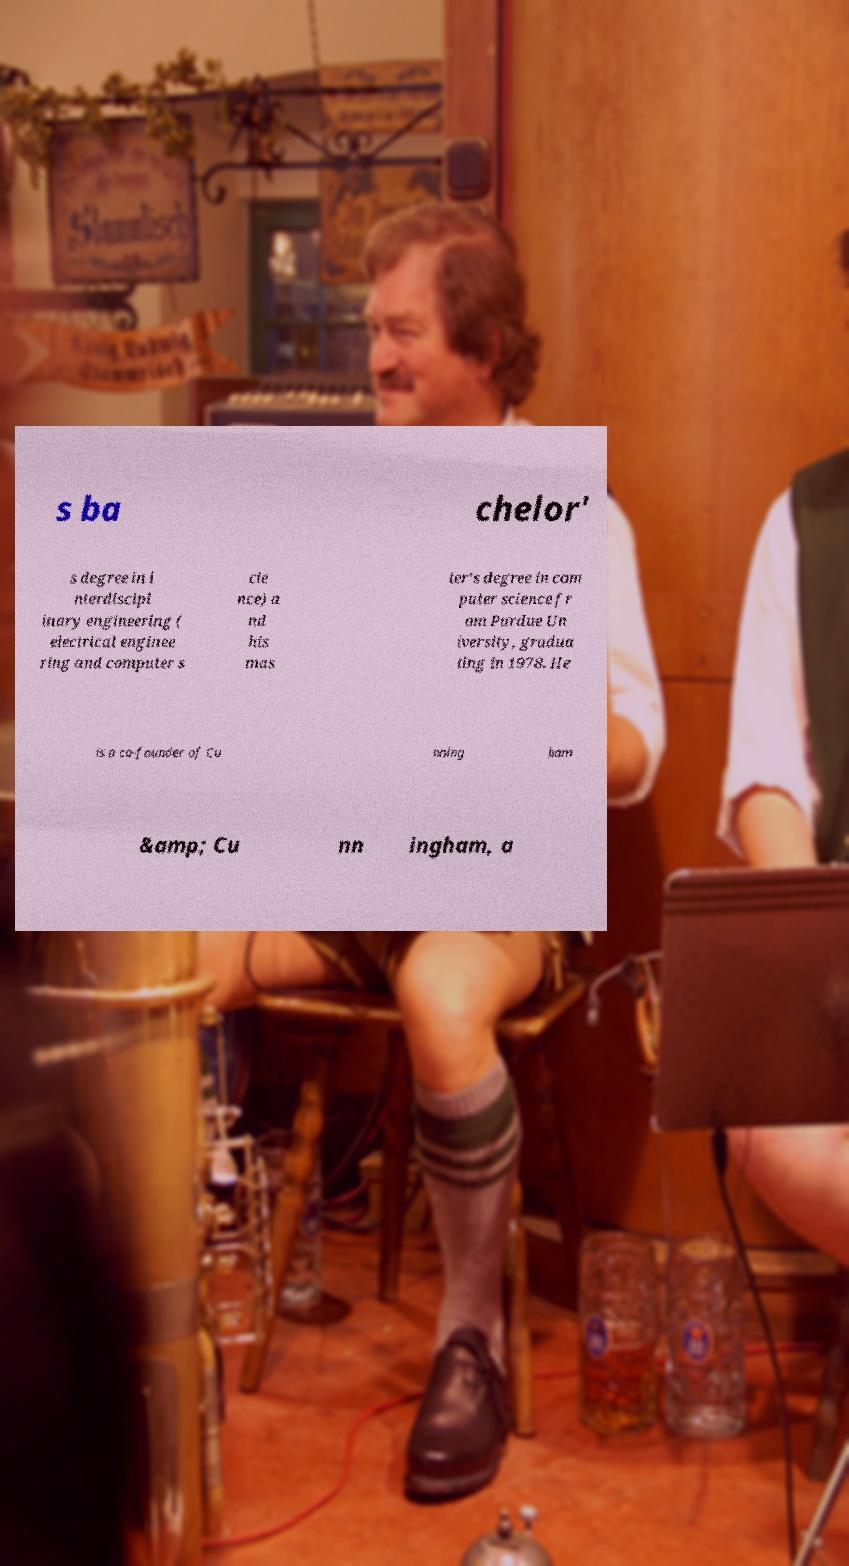Can you read and provide the text displayed in the image?This photo seems to have some interesting text. Can you extract and type it out for me? s ba chelor' s degree in i nterdiscipl inary engineering ( electrical enginee ring and computer s cie nce) a nd his mas ter's degree in com puter science fr om Purdue Un iversity, gradua ting in 1978. He is a co-founder of Cu nning ham &amp; Cu nn ingham, a 